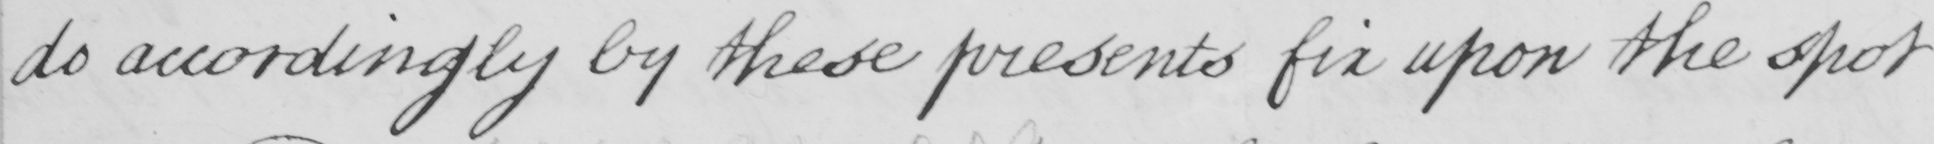Please transcribe the handwritten text in this image. do accordingly by these presents fix upon the spot 